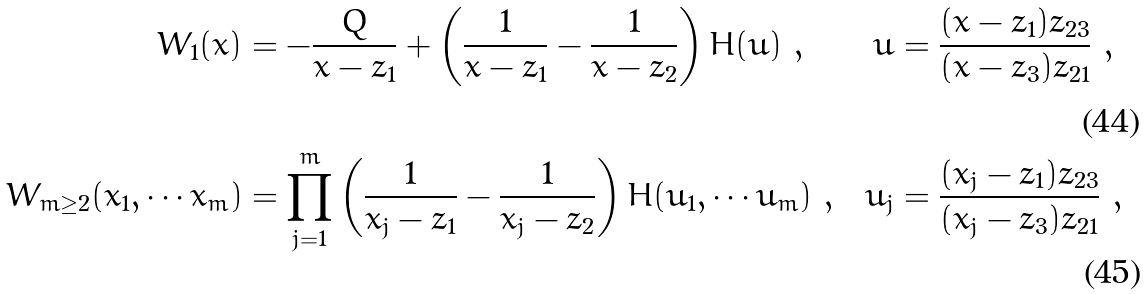Convert formula to latex. <formula><loc_0><loc_0><loc_500><loc_500>W _ { 1 } ( x ) & = - \frac { Q } { x - z _ { 1 } } + \left ( \frac { 1 } { x - z _ { 1 } } - \frac { 1 } { x - z _ { 2 } } \right ) H ( u ) \ , \ & u & = \frac { ( x - z _ { 1 } ) z _ { 2 3 } } { ( x - z _ { 3 } ) z _ { 2 1 } } \ , \\ W _ { m \geq 2 } ( x _ { 1 } , \cdots x _ { m } ) & = \prod _ { j = 1 } ^ { m } \left ( \frac { 1 } { x _ { j } - z _ { 1 } } - \frac { 1 } { x _ { j } - z _ { 2 } } \right ) H ( u _ { 1 } , \cdots u _ { m } ) \ , \ & u _ { j } & = \frac { ( x _ { j } - z _ { 1 } ) z _ { 2 3 } } { ( x _ { j } - z _ { 3 } ) z _ { 2 1 } } \ ,</formula> 